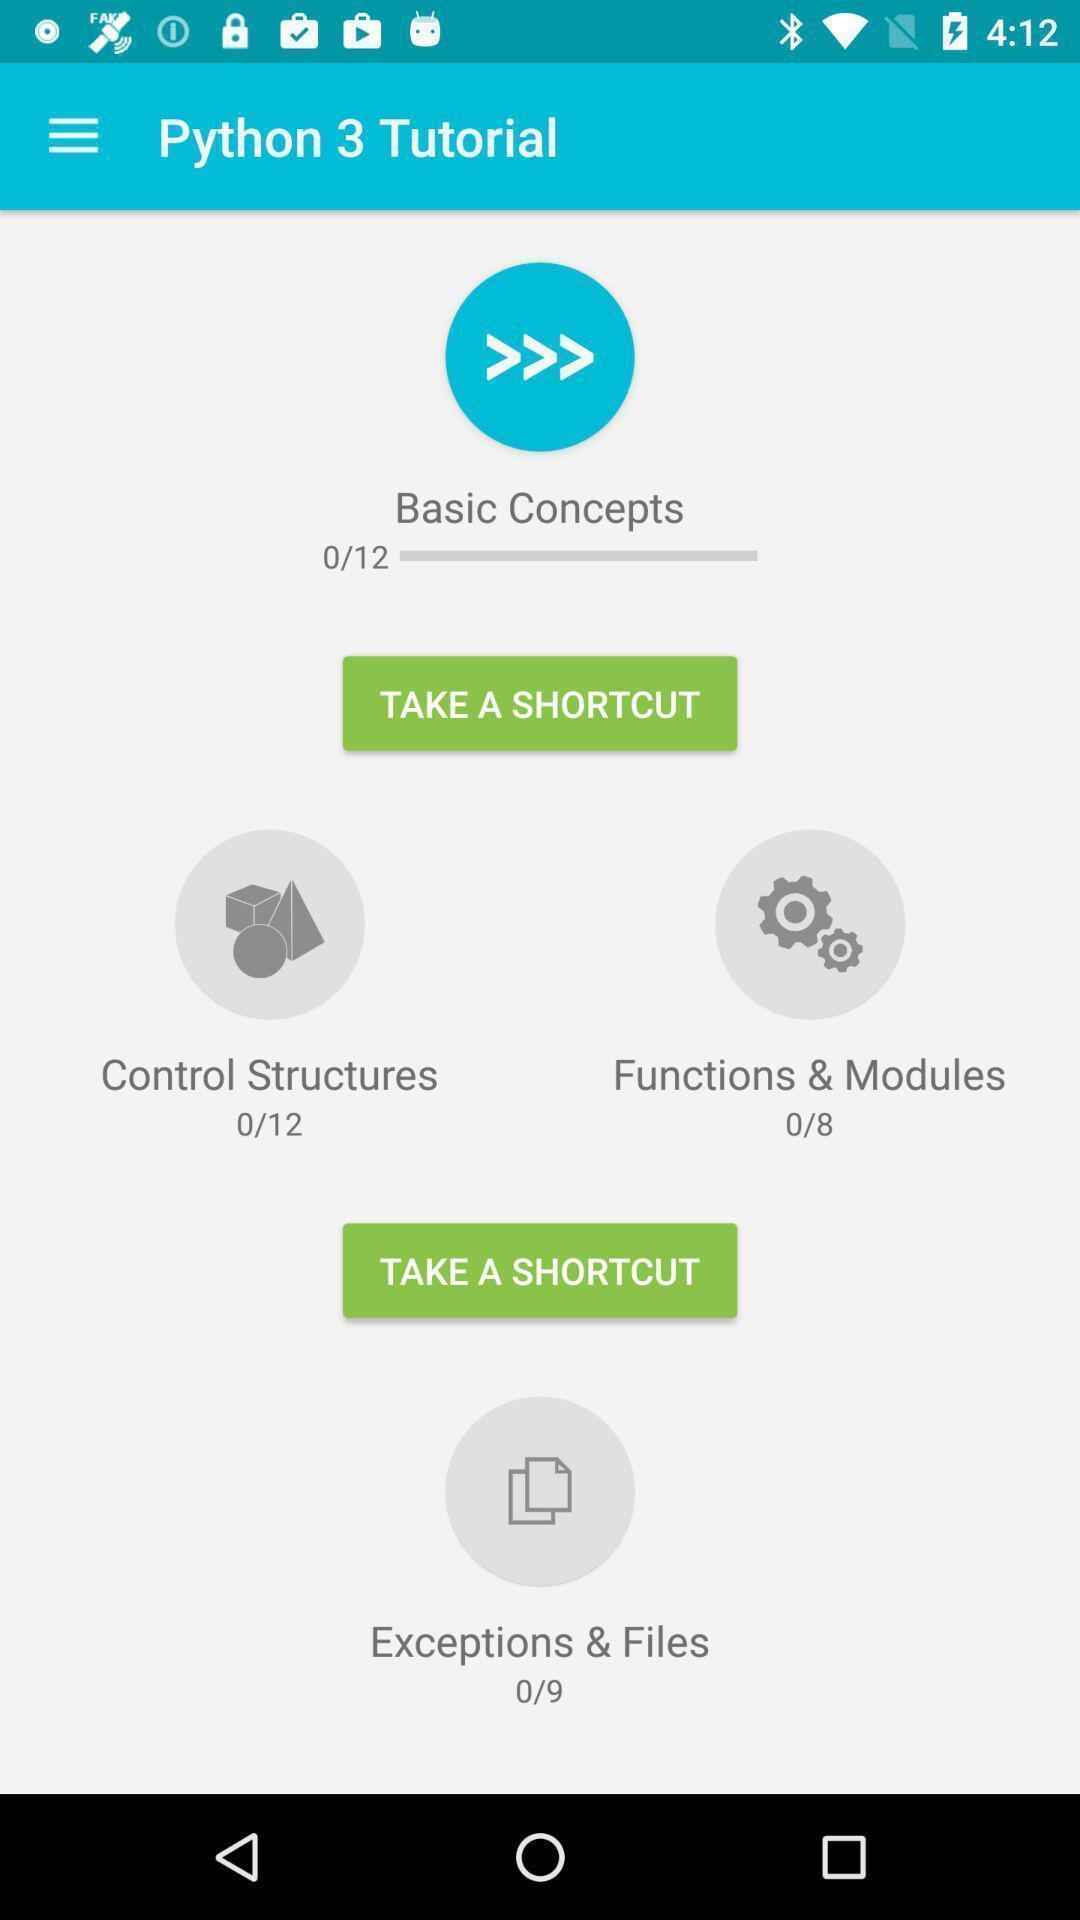Explain what's happening in this screen capture. Screen displaying multiple options in a learning application. 